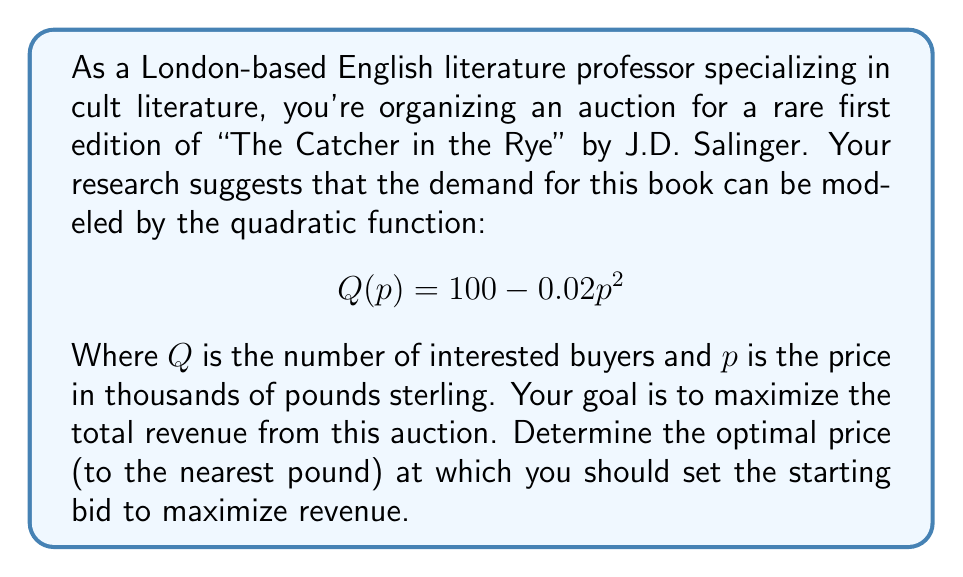Solve this math problem. To solve this problem, we need to follow these steps:

1) First, recall that revenue (R) is the product of price (p) and quantity (Q):
   $$R = p \cdot Q$$

2) Substitute the given demand function into the revenue equation:
   $$R(p) = p \cdot (100 - 0.02p^2)$$

3) Expand this equation:
   $$R(p) = 100p - 0.02p^3$$

4) To find the maximum revenue, we need to find the value of p where the derivative of R(p) equals zero:
   $$\frac{dR}{dp} = 100 - 0.06p^2$$

5) Set this equal to zero and solve for p:
   $$100 - 0.06p^2 = 0$$
   $$0.06p^2 = 100$$
   $$p^2 = \frac{100}{0.06} \approx 1666.67$$
   $$p \approx \sqrt{1666.67} \approx 40.82$$

6) To confirm this is a maximum, we can check the second derivative:
   $$\frac{d^2R}{dp^2} = -0.12p$$
   This is negative when p is positive, confirming a maximum.

7) Since we're dealing with currency, we need to round to the nearest pound. Therefore, the optimal price is £40,825.

8) To verify, we can calculate the revenue at this price and at prices slightly above and below:
   At £40,825: R = 40.825 * (100 - 0.02 * 40.825^2) ≈ 1666.65 thousand pounds
   At £40,824: R = 40.824 * (100 - 0.02 * 40.824^2) ≈ 1666.65 thousand pounds
   At £40,826: R = 40.826 * (100 - 0.02 * 40.826^2) ≈ 1666.65 thousand pounds

   This confirms that £40,825 yields the maximum revenue.
Answer: The optimal starting bid for the rare first edition of "The Catcher in the Rye" should be set at £40,825 to maximize revenue. 